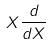Convert formula to latex. <formula><loc_0><loc_0><loc_500><loc_500>X \frac { d } { d X }</formula> 